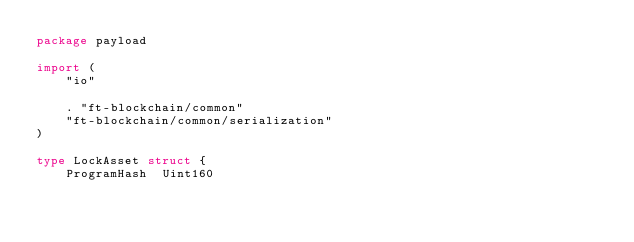<code> <loc_0><loc_0><loc_500><loc_500><_Go_>package payload

import (
	"io"

	. "ft-blockchain/common"
	"ft-blockchain/common/serialization"
)

type LockAsset struct {
	ProgramHash  Uint160</code> 